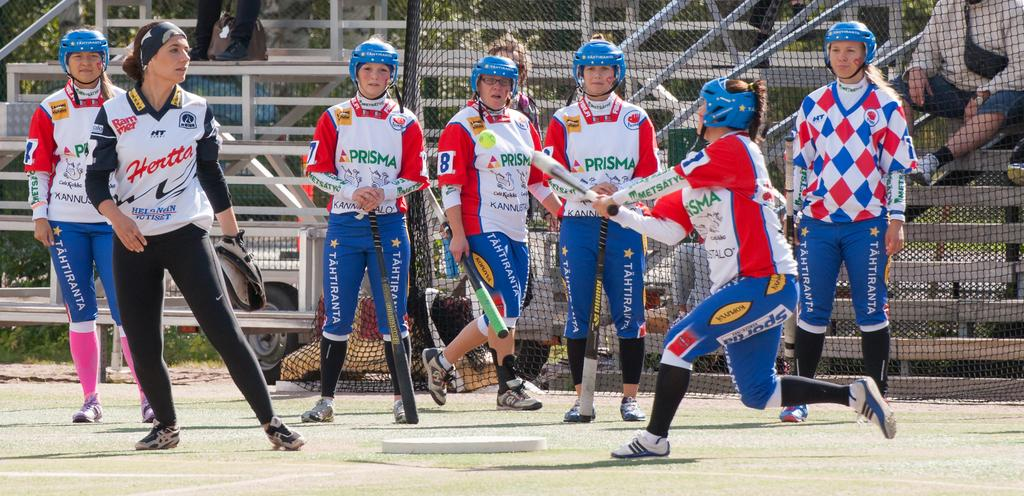<image>
Offer a succinct explanation of the picture presented. A group of female athletes wear colorful uniforms with Prisma written on the front. 